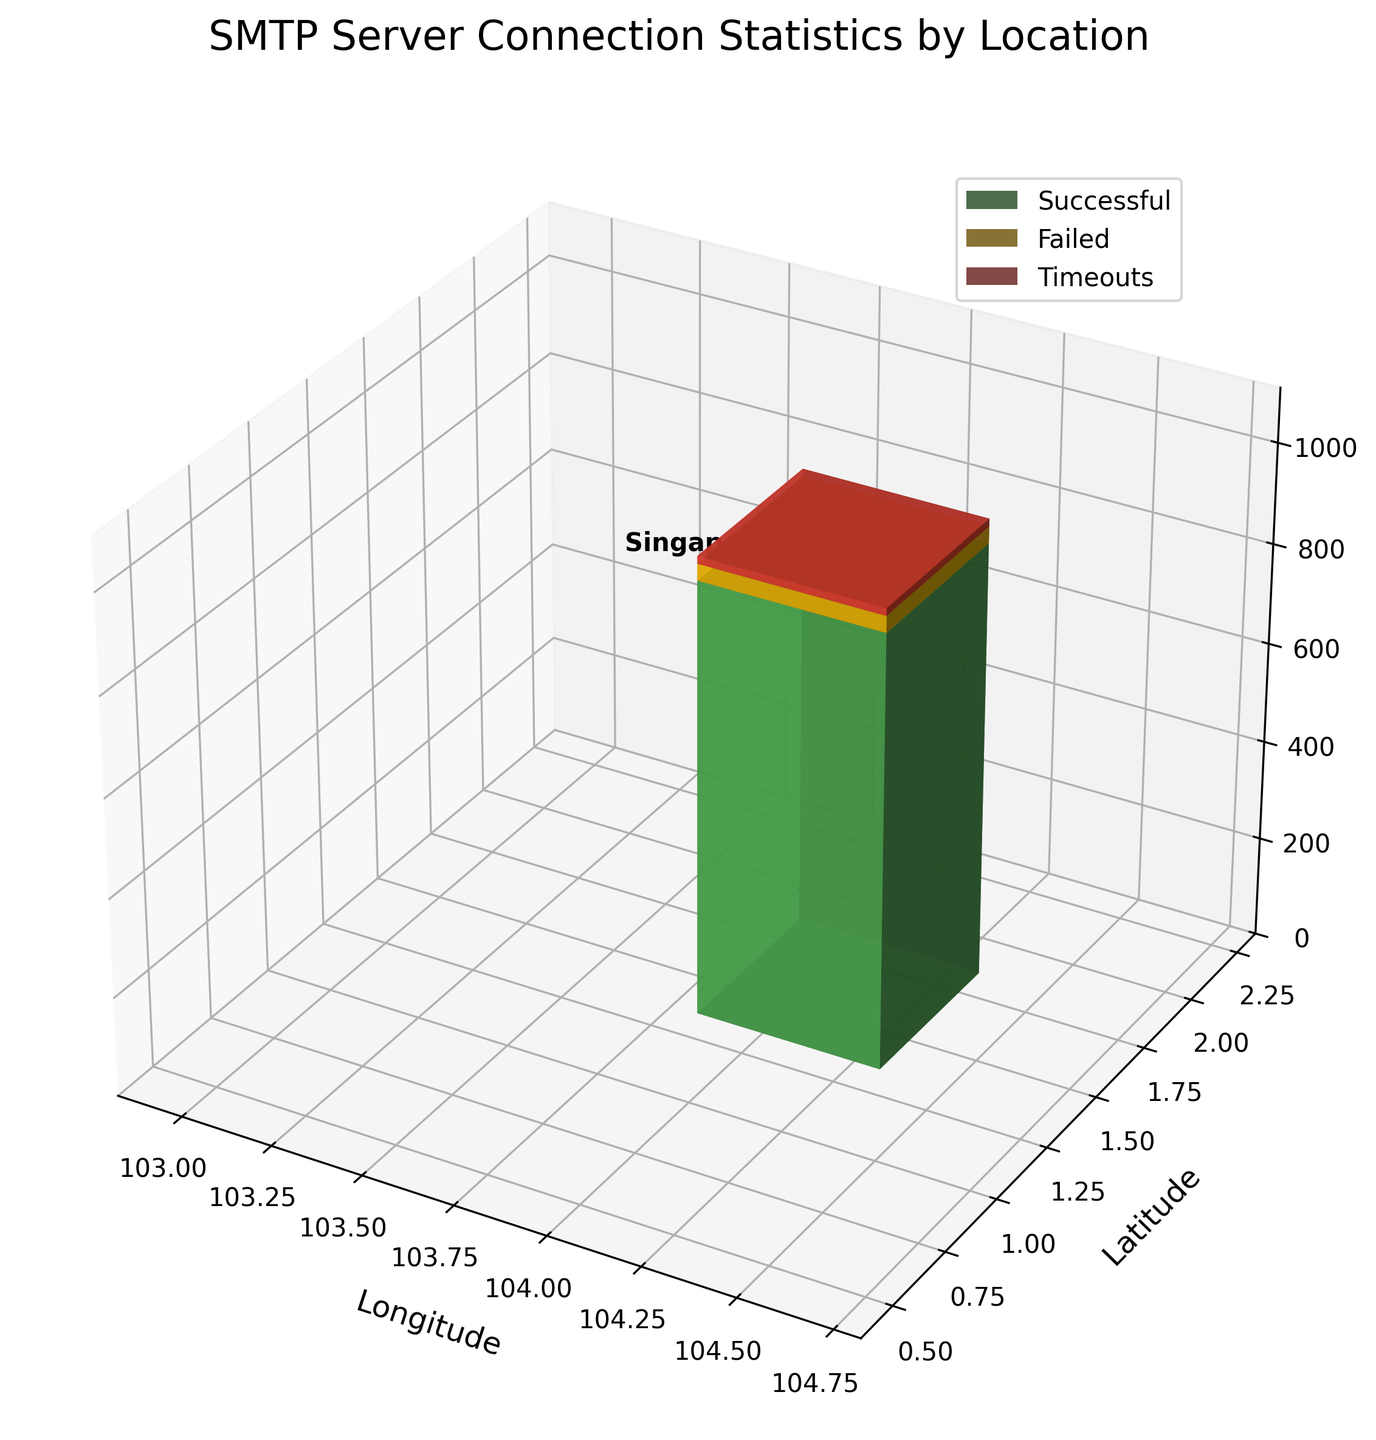What is the title of the 3D plot? The title is shown at the top of the figure and provides a brief description of what the plot represents.
Answer: SMTP Server Connection Statistics by Location What are the labels for the x, y, and z axes? The axis labels provide context for what each axis represents. The x-axis represents Longitude, the y-axis represents Latitude, and the z-axis represents Connections.
Answer: Longitude, Latitude, Connections How many locations are represented in the plot? By counting the number of distinct data points in the plot, we determine that there is one location, which is Singapore.
Answer: 1 Which color represents successful connections? The figure legend shows that successful connections are represented by the color green.
Answer: Green Which connection type has the highest value in Singapore? From the height of the bars in the 3D plot for Singapore, the green bar representing Successful connections is the highest.
Answer: Successful What is the sum of failed attempts and timeouts in Singapore? To find the sum, we add the values represented by the yellow and red bars: 33 (Failed) + 15 (Timeouts) = 48.
Answer: 48 Which type of connections has the lowest count in Singapore, and what is its value? By examining the heights of the bars, we see that the red bar for Timeouts is the shortest and the value given is 15.
Answer: Timeouts, 15 What is the total number of connections (successful, failed, and timeouts) in Singapore? The total number of connections can be found by adding the values for all three types: 875 (Successful) + 33 (Failed) + 15 (Timeouts) = 923.
Answer: 923 Among the connection types (successful, failed, timeouts), which has a higher count: failed attempts or timeouts, and by how much? By comparing the heights of the bars, Failed attempts (33) is higher than Timeouts (15). The difference is 33 - 15 = 18.
Answer: Failed attempts by 18 What are the longitude and latitude coordinates for Singapore in the plot? The plot shows the data point for Singapore with coordinates 103.8198 (Longitude) and 1.3521 (Latitude).
Answer: 103.8198, 1.3521 